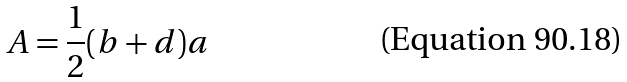<formula> <loc_0><loc_0><loc_500><loc_500>A = \frac { 1 } { 2 } ( b + d ) a</formula> 